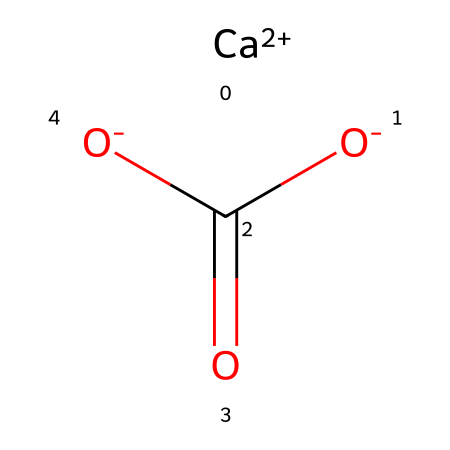What type of ion is present in this compound? The compound contains a calcium ion, indicated by [Ca+2], which represents a divalent cation commonly found in various minerals.
Answer: calcium How many carboxylate groups are there? The structure has one carboxylate group, identified by the -C(=O)[O-] part, which reveals one carbon atom double-bonded to oxygen and single-bonded to another oxygen.
Answer: one What is the oxidation state of calcium in this compound? The oxidation state of calcium in this compound is +2, as indicated by the [Ca+2] notation.
Answer: +2 What is the overall charge of this compound? The overall charge is neutral, since the calcium ion (+2) balances with the two negative charges from the carboxylate group (-2).
Answer: neutral Is this compound likely to form salts? Yes, this compound can form salts, as it contains a metal ion and a carboxylate group that can react with anions to produce various salts.
Answer: yes Which functional group is identified in this chemical structure? The functional group present is the carboxylate group, as indicated by the -C(=O)[O-] portion of the structure.
Answer: carboxylate 